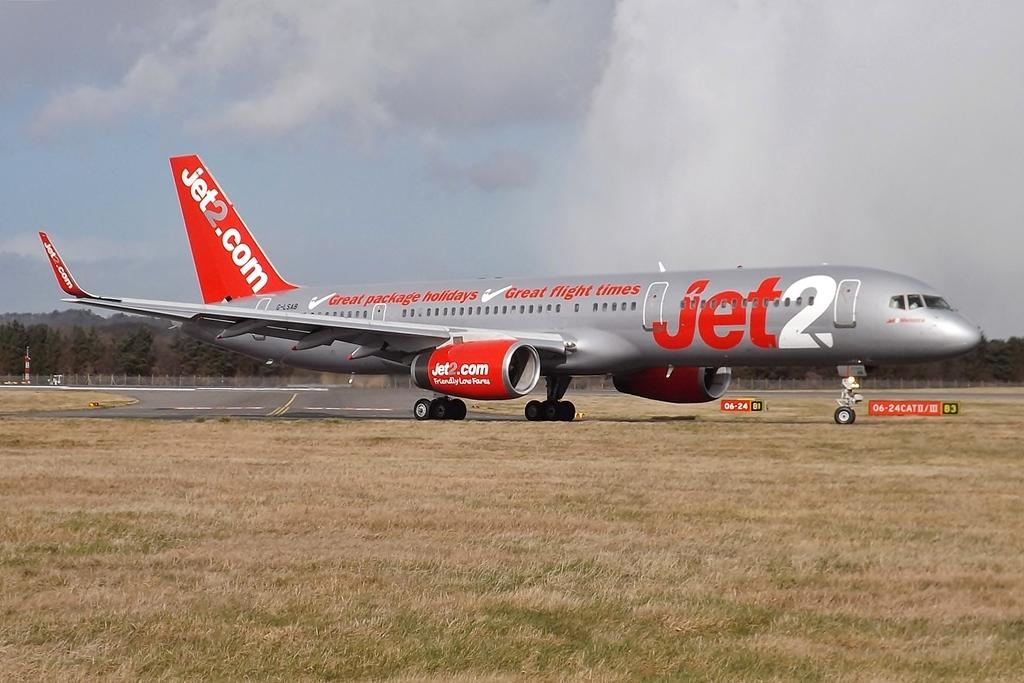What website is on the wing of plane?
Give a very brief answer. Jet2.com. On the plane it says jet what in the front ?
Your answer should be very brief. 2. 